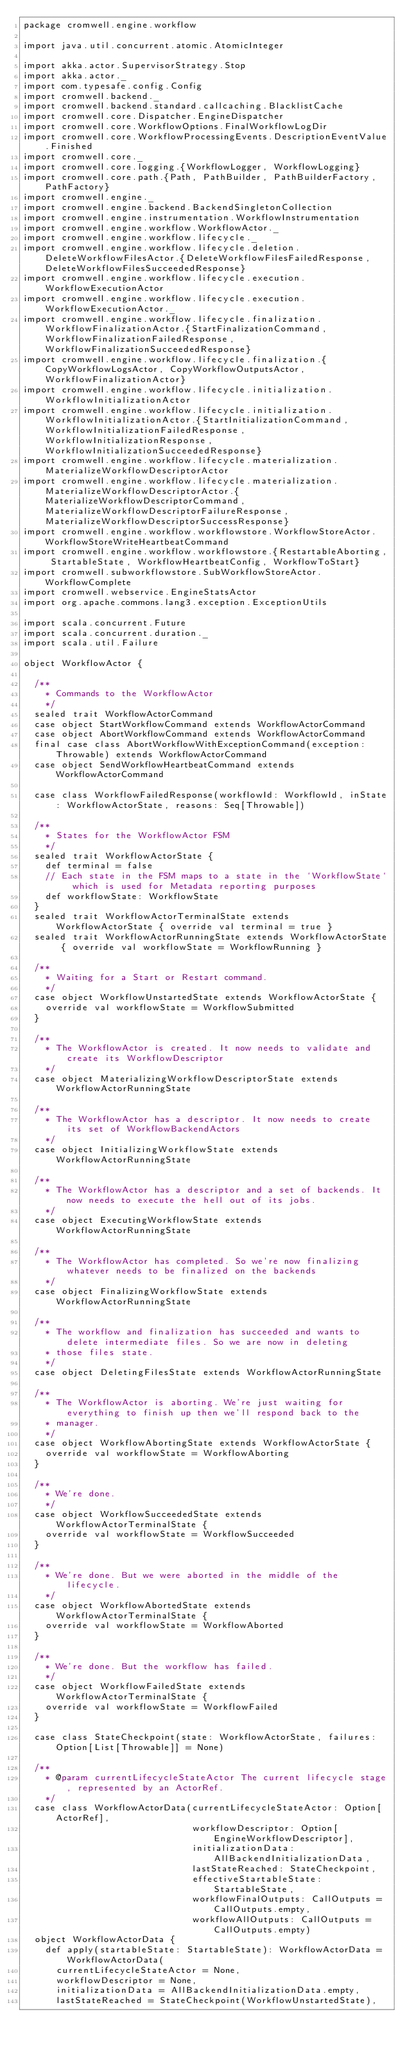Convert code to text. <code><loc_0><loc_0><loc_500><loc_500><_Scala_>package cromwell.engine.workflow

import java.util.concurrent.atomic.AtomicInteger

import akka.actor.SupervisorStrategy.Stop
import akka.actor._
import com.typesafe.config.Config
import cromwell.backend._
import cromwell.backend.standard.callcaching.BlacklistCache
import cromwell.core.Dispatcher.EngineDispatcher
import cromwell.core.WorkflowOptions.FinalWorkflowLogDir
import cromwell.core.WorkflowProcessingEvents.DescriptionEventValue.Finished
import cromwell.core._
import cromwell.core.logging.{WorkflowLogger, WorkflowLogging}
import cromwell.core.path.{Path, PathBuilder, PathBuilderFactory, PathFactory}
import cromwell.engine._
import cromwell.engine.backend.BackendSingletonCollection
import cromwell.engine.instrumentation.WorkflowInstrumentation
import cromwell.engine.workflow.WorkflowActor._
import cromwell.engine.workflow.lifecycle._
import cromwell.engine.workflow.lifecycle.deletion.DeleteWorkflowFilesActor.{DeleteWorkflowFilesFailedResponse, DeleteWorkflowFilesSucceededResponse}
import cromwell.engine.workflow.lifecycle.execution.WorkflowExecutionActor
import cromwell.engine.workflow.lifecycle.execution.WorkflowExecutionActor._
import cromwell.engine.workflow.lifecycle.finalization.WorkflowFinalizationActor.{StartFinalizationCommand, WorkflowFinalizationFailedResponse, WorkflowFinalizationSucceededResponse}
import cromwell.engine.workflow.lifecycle.finalization.{CopyWorkflowLogsActor, CopyWorkflowOutputsActor, WorkflowFinalizationActor}
import cromwell.engine.workflow.lifecycle.initialization.WorkflowInitializationActor
import cromwell.engine.workflow.lifecycle.initialization.WorkflowInitializationActor.{StartInitializationCommand, WorkflowInitializationFailedResponse, WorkflowInitializationResponse, WorkflowInitializationSucceededResponse}
import cromwell.engine.workflow.lifecycle.materialization.MaterializeWorkflowDescriptorActor
import cromwell.engine.workflow.lifecycle.materialization.MaterializeWorkflowDescriptorActor.{MaterializeWorkflowDescriptorCommand, MaterializeWorkflowDescriptorFailureResponse, MaterializeWorkflowDescriptorSuccessResponse}
import cromwell.engine.workflow.workflowstore.WorkflowStoreActor.WorkflowStoreWriteHeartbeatCommand
import cromwell.engine.workflow.workflowstore.{RestartableAborting, StartableState, WorkflowHeartbeatConfig, WorkflowToStart}
import cromwell.subworkflowstore.SubWorkflowStoreActor.WorkflowComplete
import cromwell.webservice.EngineStatsActor
import org.apache.commons.lang3.exception.ExceptionUtils

import scala.concurrent.Future
import scala.concurrent.duration._
import scala.util.Failure

object WorkflowActor {

  /**
    * Commands to the WorkflowActor
    */
  sealed trait WorkflowActorCommand
  case object StartWorkflowCommand extends WorkflowActorCommand
  case object AbortWorkflowCommand extends WorkflowActorCommand
  final case class AbortWorkflowWithExceptionCommand(exception: Throwable) extends WorkflowActorCommand
  case object SendWorkflowHeartbeatCommand extends WorkflowActorCommand

  case class WorkflowFailedResponse(workflowId: WorkflowId, inState: WorkflowActorState, reasons: Seq[Throwable])

  /**
    * States for the WorkflowActor FSM
    */
  sealed trait WorkflowActorState {
    def terminal = false
    // Each state in the FSM maps to a state in the `WorkflowState` which is used for Metadata reporting purposes
    def workflowState: WorkflowState
  }
  sealed trait WorkflowActorTerminalState extends WorkflowActorState { override val terminal = true }
  sealed trait WorkflowActorRunningState extends WorkflowActorState { override val workflowState = WorkflowRunning }

  /**
    * Waiting for a Start or Restart command.
    */
  case object WorkflowUnstartedState extends WorkflowActorState {
    override val workflowState = WorkflowSubmitted
  }

  /**
    * The WorkflowActor is created. It now needs to validate and create its WorkflowDescriptor
    */
  case object MaterializingWorkflowDescriptorState extends WorkflowActorRunningState

  /**
    * The WorkflowActor has a descriptor. It now needs to create its set of WorkflowBackendActors
    */
  case object InitializingWorkflowState extends WorkflowActorRunningState

  /**
    * The WorkflowActor has a descriptor and a set of backends. It now needs to execute the hell out of its jobs.
    */
  case object ExecutingWorkflowState extends WorkflowActorRunningState

  /**
    * The WorkflowActor has completed. So we're now finalizing whatever needs to be finalized on the backends
    */
  case object FinalizingWorkflowState extends WorkflowActorRunningState

  /**
    * The workflow and finalization has succeeded and wants to delete intermediate files. So we are now in deleting
    * those files state.
    */
  case object DeletingFilesState extends WorkflowActorRunningState

  /**
    * The WorkflowActor is aborting. We're just waiting for everything to finish up then we'll respond back to the
    * manager.
    */
  case object WorkflowAbortingState extends WorkflowActorState {
    override val workflowState = WorkflowAborting
  }

  /**
    * We're done.
    */
  case object WorkflowSucceededState extends WorkflowActorTerminalState {
    override val workflowState = WorkflowSucceeded
  }

  /**
    * We're done. But we were aborted in the middle of the lifecycle.
    */
  case object WorkflowAbortedState extends WorkflowActorTerminalState {
    override val workflowState = WorkflowAborted
  }

  /**
    * We're done. But the workflow has failed.
    */
  case object WorkflowFailedState extends WorkflowActorTerminalState {
    override val workflowState = WorkflowFailed
  }

  case class StateCheckpoint(state: WorkflowActorState, failures: Option[List[Throwable]] = None)

  /**
    * @param currentLifecycleStateActor The current lifecycle stage, represented by an ActorRef.
    */
  case class WorkflowActorData(currentLifecycleStateActor: Option[ActorRef],
                               workflowDescriptor: Option[EngineWorkflowDescriptor],
                               initializationData: AllBackendInitializationData,
                               lastStateReached: StateCheckpoint,
                               effectiveStartableState: StartableState,
                               workflowFinalOutputs: CallOutputs = CallOutputs.empty,
                               workflowAllOutputs: CallOutputs = CallOutputs.empty)
  object WorkflowActorData {
    def apply(startableState: StartableState): WorkflowActorData = WorkflowActorData(
      currentLifecycleStateActor = None,
      workflowDescriptor = None,
      initializationData = AllBackendInitializationData.empty,
      lastStateReached = StateCheckpoint(WorkflowUnstartedState),</code> 